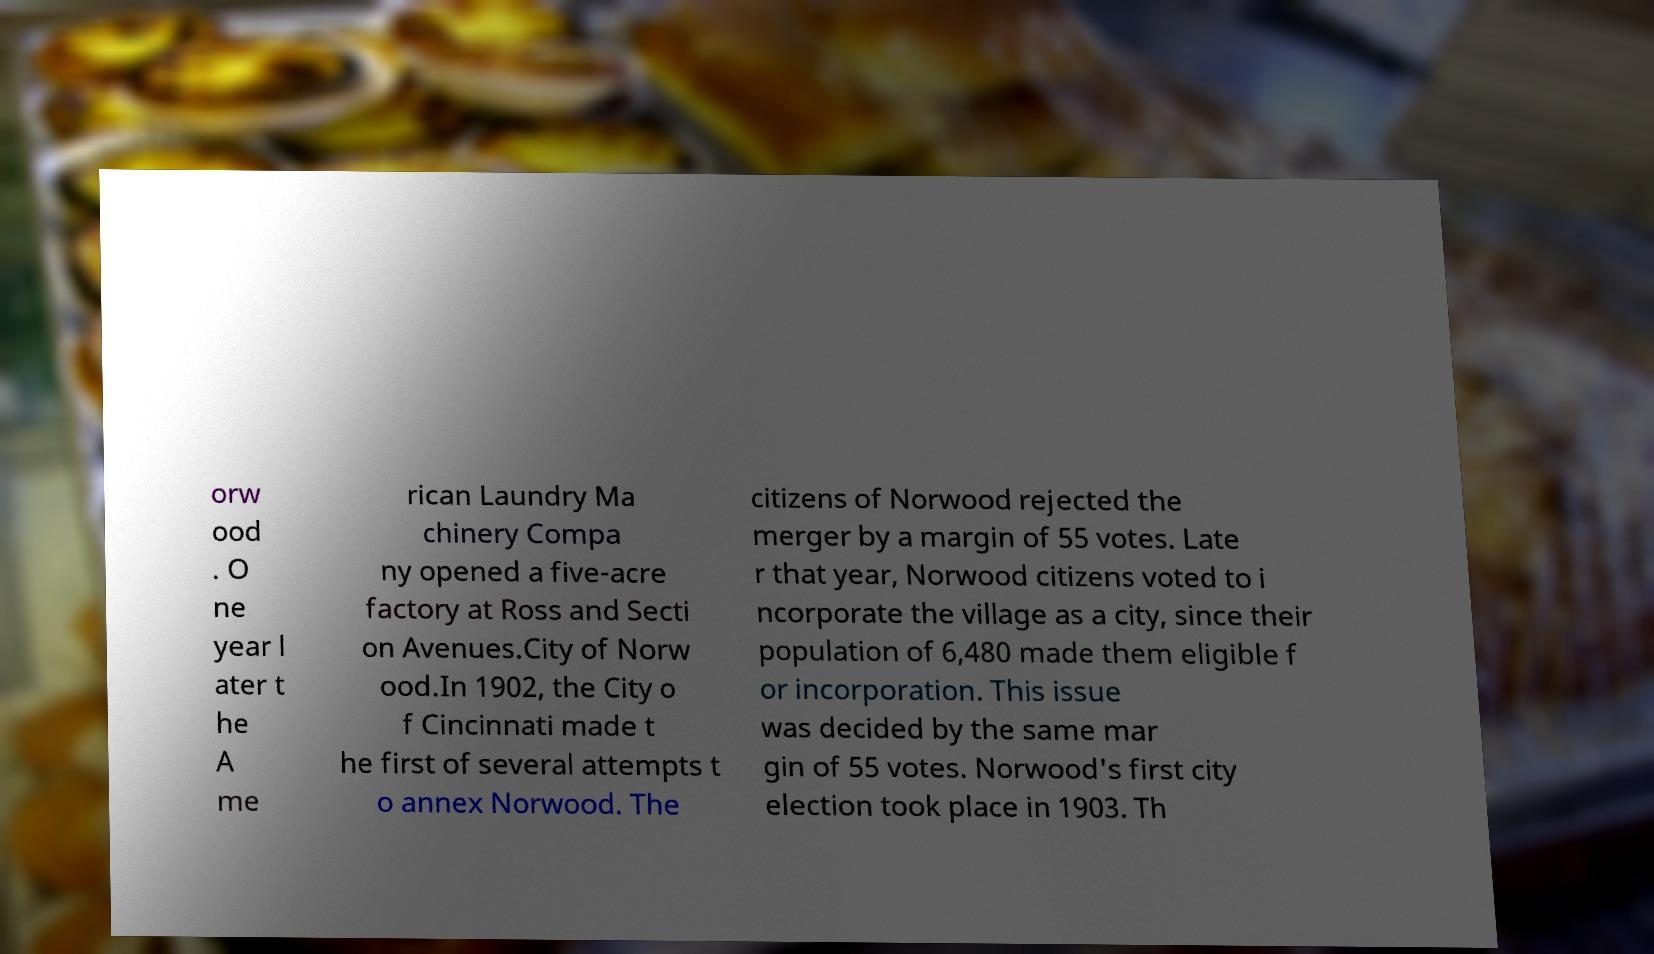Please read and relay the text visible in this image. What does it say? orw ood . O ne year l ater t he A me rican Laundry Ma chinery Compa ny opened a five-acre factory at Ross and Secti on Avenues.City of Norw ood.In 1902, the City o f Cincinnati made t he first of several attempts t o annex Norwood. The citizens of Norwood rejected the merger by a margin of 55 votes. Late r that year, Norwood citizens voted to i ncorporate the village as a city, since their population of 6,480 made them eligible f or incorporation. This issue was decided by the same mar gin of 55 votes. Norwood's first city election took place in 1903. Th 